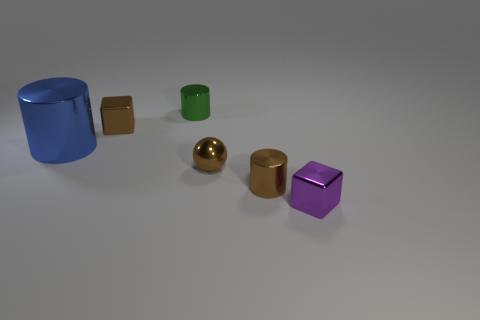Subtract all small metallic cylinders. How many cylinders are left? 1 Subtract 3 cylinders. How many cylinders are left? 0 Add 1 brown metallic cylinders. How many objects exist? 7 Subtract all brown blocks. How many blocks are left? 1 Subtract 0 gray cylinders. How many objects are left? 6 Subtract all cubes. How many objects are left? 4 Subtract all cyan blocks. Subtract all purple cylinders. How many blocks are left? 2 Subtract all blue blocks. How many red balls are left? 0 Subtract all brown cylinders. Subtract all tiny gray shiny cylinders. How many objects are left? 5 Add 1 green metal objects. How many green metal objects are left? 2 